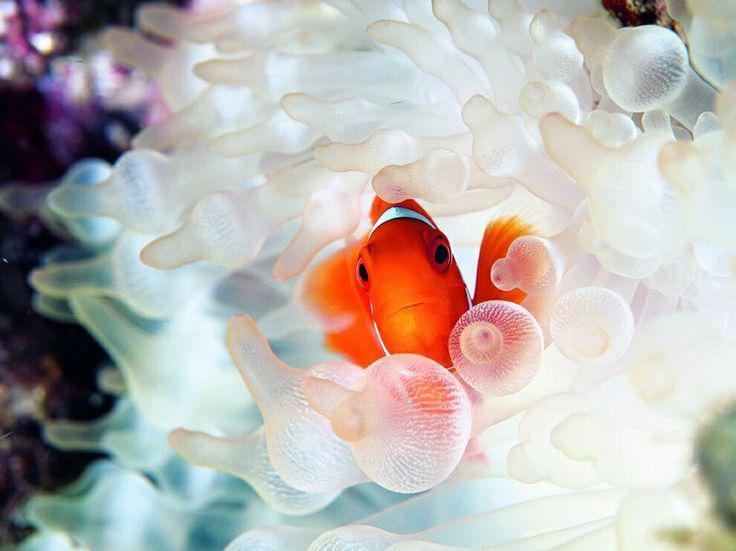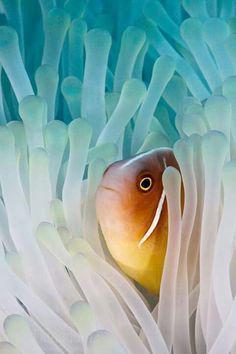The first image is the image on the left, the second image is the image on the right. Analyze the images presented: Is the assertion "Each image shows one black-eyed clown fish within the white, slender tendrils of an anemone." valid? Answer yes or no. No. 